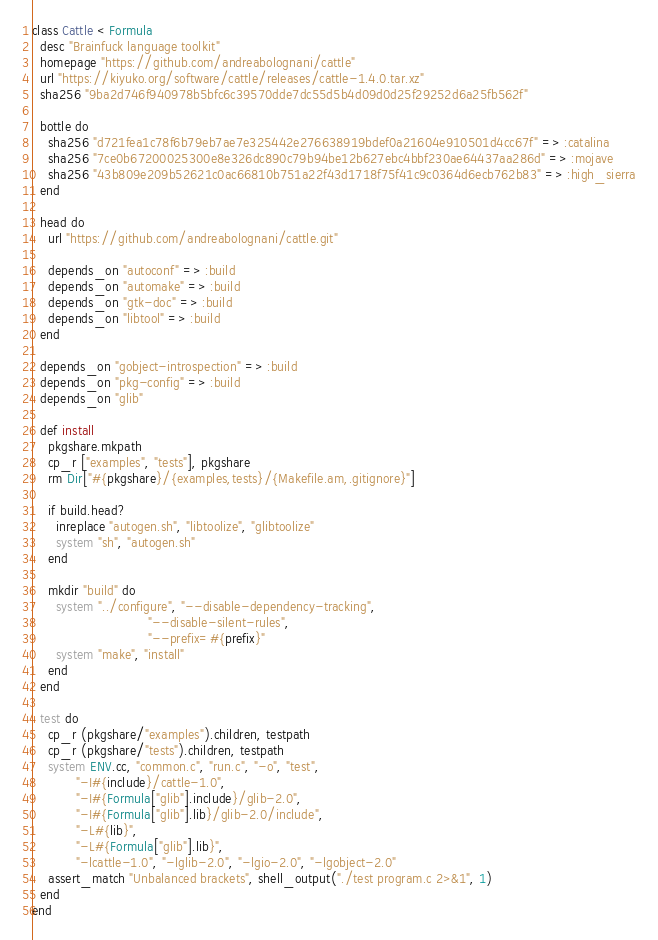<code> <loc_0><loc_0><loc_500><loc_500><_Ruby_>class Cattle < Formula
  desc "Brainfuck language toolkit"
  homepage "https://github.com/andreabolognani/cattle"
  url "https://kiyuko.org/software/cattle/releases/cattle-1.4.0.tar.xz"
  sha256 "9ba2d746f940978b5bfc6c39570dde7dc55d5b4d09d0d25f29252d6a25fb562f"

  bottle do
    sha256 "d721fea1c78f6b79eb7ae7e325442e276638919bdef0a21604e910501d4cc67f" => :catalina
    sha256 "7ce0b67200025300e8e326dc890c79b94be12b627ebc4bbf230ae64437aa286d" => :mojave
    sha256 "43b809e209b52621c0ac66810b751a22f43d1718f75f41c9c0364d6ecb762b83" => :high_sierra
  end

  head do
    url "https://github.com/andreabolognani/cattle.git"

    depends_on "autoconf" => :build
    depends_on "automake" => :build
    depends_on "gtk-doc" => :build
    depends_on "libtool" => :build
  end

  depends_on "gobject-introspection" => :build
  depends_on "pkg-config" => :build
  depends_on "glib"

  def install
    pkgshare.mkpath
    cp_r ["examples", "tests"], pkgshare
    rm Dir["#{pkgshare}/{examples,tests}/{Makefile.am,.gitignore}"]

    if build.head?
      inreplace "autogen.sh", "libtoolize", "glibtoolize"
      system "sh", "autogen.sh"
    end

    mkdir "build" do
      system "../configure", "--disable-dependency-tracking",
                             "--disable-silent-rules",
                             "--prefix=#{prefix}"
      system "make", "install"
    end
  end

  test do
    cp_r (pkgshare/"examples").children, testpath
    cp_r (pkgshare/"tests").children, testpath
    system ENV.cc, "common.c", "run.c", "-o", "test",
           "-I#{include}/cattle-1.0",
           "-I#{Formula["glib"].include}/glib-2.0",
           "-I#{Formula["glib"].lib}/glib-2.0/include",
           "-L#{lib}",
           "-L#{Formula["glib"].lib}",
           "-lcattle-1.0", "-lglib-2.0", "-lgio-2.0", "-lgobject-2.0"
    assert_match "Unbalanced brackets", shell_output("./test program.c 2>&1", 1)
  end
end
</code> 